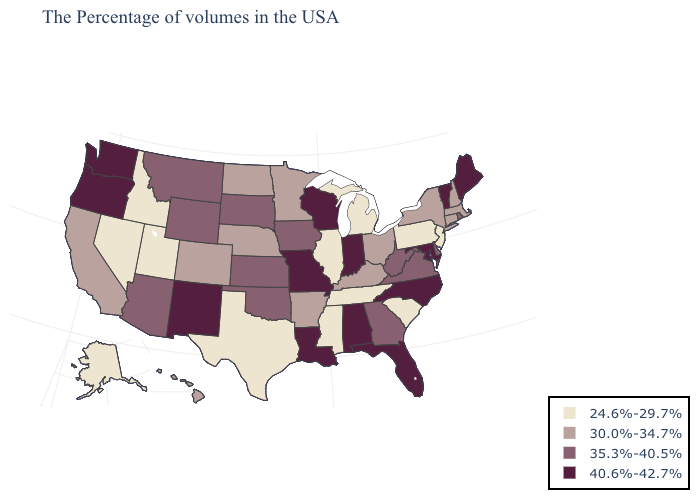What is the value of North Carolina?
Concise answer only. 40.6%-42.7%. Is the legend a continuous bar?
Be succinct. No. Does Texas have the lowest value in the USA?
Concise answer only. Yes. Name the states that have a value in the range 40.6%-42.7%?
Be succinct. Maine, Vermont, Maryland, North Carolina, Florida, Indiana, Alabama, Wisconsin, Louisiana, Missouri, New Mexico, Washington, Oregon. What is the value of Virginia?
Quick response, please. 35.3%-40.5%. What is the lowest value in the South?
Concise answer only. 24.6%-29.7%. Is the legend a continuous bar?
Quick response, please. No. Name the states that have a value in the range 35.3%-40.5%?
Answer briefly. Rhode Island, Delaware, Virginia, West Virginia, Georgia, Iowa, Kansas, Oklahoma, South Dakota, Wyoming, Montana, Arizona. Name the states that have a value in the range 24.6%-29.7%?
Quick response, please. New Jersey, Pennsylvania, South Carolina, Michigan, Tennessee, Illinois, Mississippi, Texas, Utah, Idaho, Nevada, Alaska. Among the states that border California , which have the lowest value?
Be succinct. Nevada. Which states have the lowest value in the MidWest?
Short answer required. Michigan, Illinois. Does the map have missing data?
Concise answer only. No. Which states have the lowest value in the USA?
Give a very brief answer. New Jersey, Pennsylvania, South Carolina, Michigan, Tennessee, Illinois, Mississippi, Texas, Utah, Idaho, Nevada, Alaska. Which states have the lowest value in the Northeast?
Answer briefly. New Jersey, Pennsylvania. What is the highest value in states that border Mississippi?
Keep it brief. 40.6%-42.7%. 